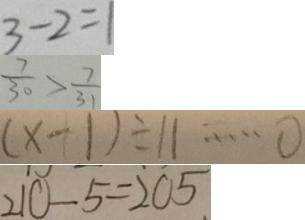Convert formula to latex. <formula><loc_0><loc_0><loc_500><loc_500>3 - 2 = 1 
 \frac { 7 } { 3 0 } > \frac { 7 } { 3 1 } 
 ( x - 1 ) \div 1 1 \cdots 0 
 2 1 0 - 5 = 2 0 5</formula> 